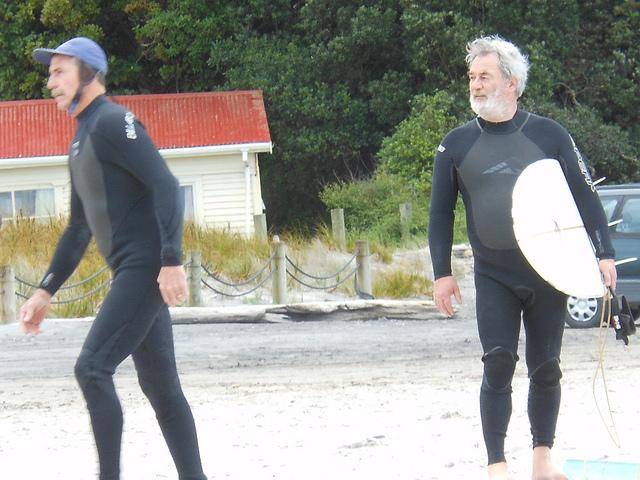Where do these men want to go next? ocean 